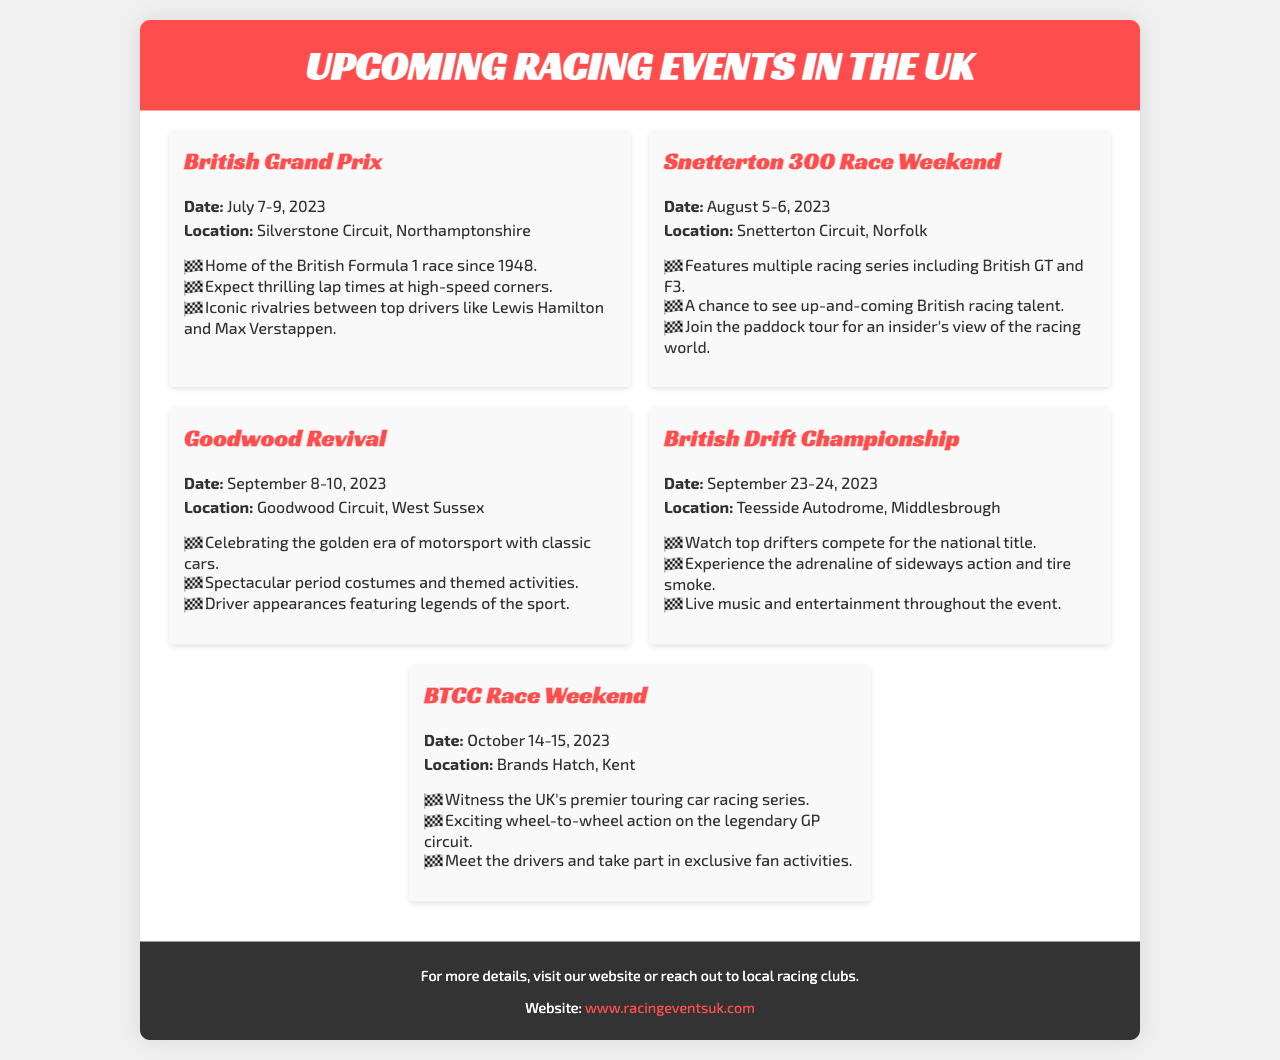What is the date of the British Grand Prix? The British Grand Prix takes place from July 7-9, 2023.
Answer: July 7-9, 2023 Where is the Snetterton 300 Race Weekend held? The Snetterton 300 Race Weekend is held at Snetterton Circuit, Norfolk.
Answer: Snetterton Circuit, Norfolk What type of event is the Goodwood Revival? The Goodwood Revival celebrates the golden era of motorsport with classic cars.
Answer: Classic cars What is a highlight of the British Drift Championship? One highlight is watching top drifters compete for the national title.
Answer: Top drifters compete How many events are listed in the brochure? The brochure lists a total of five upcoming racing events.
Answer: Five events Which racing series takes place at Brands Hatch? The event at Brands Hatch features the UK's premier touring car racing series, BTCC.
Answer: BTCC What is the primary focus of the Goodwood Revival? The primary focus of the Goodwood Revival is classic motorsport.
Answer: Classic motorsport What type of activities can fans participate in during the BTCC Race Weekend? Fans can take part in exclusive fan activities during the BTCC Race Weekend.
Answer: Exclusive fan activities 